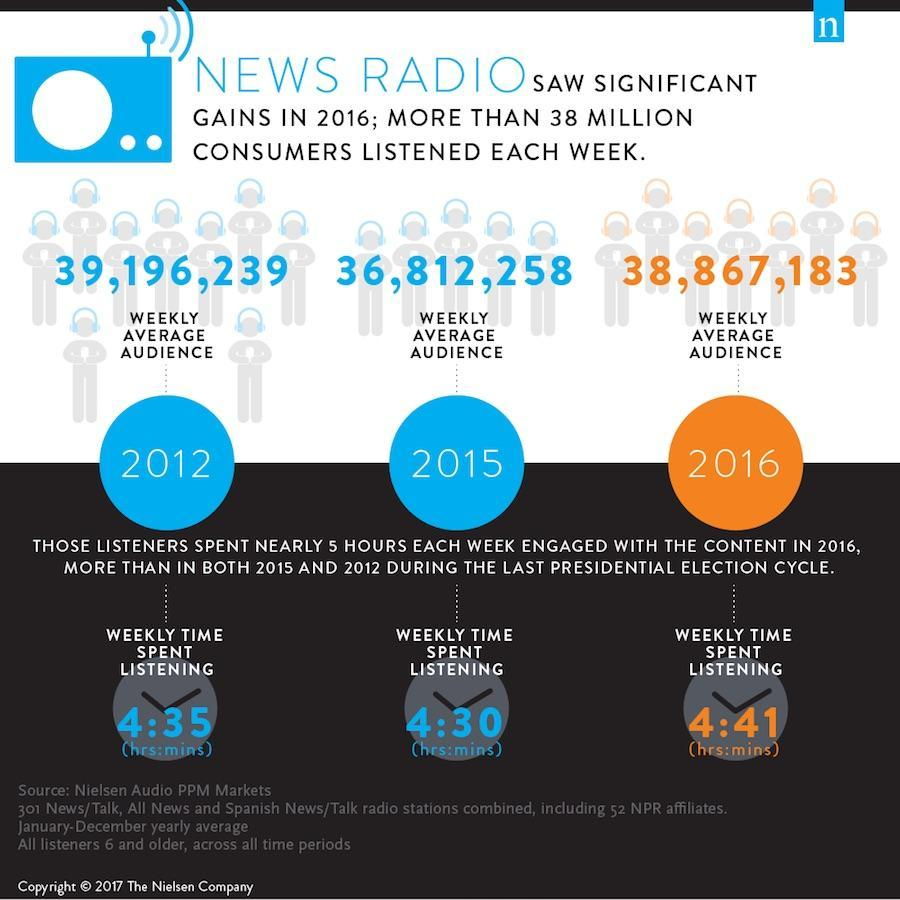What is the number of weakly average audience for news radio in 2012?
Answer the question with a short phrase. 39,196,239 How much time (hrs:mins) is spend listening to news radio in 2016? 4:41 What is the number of weakly average audience for news radio in 2015? 36,812,258 